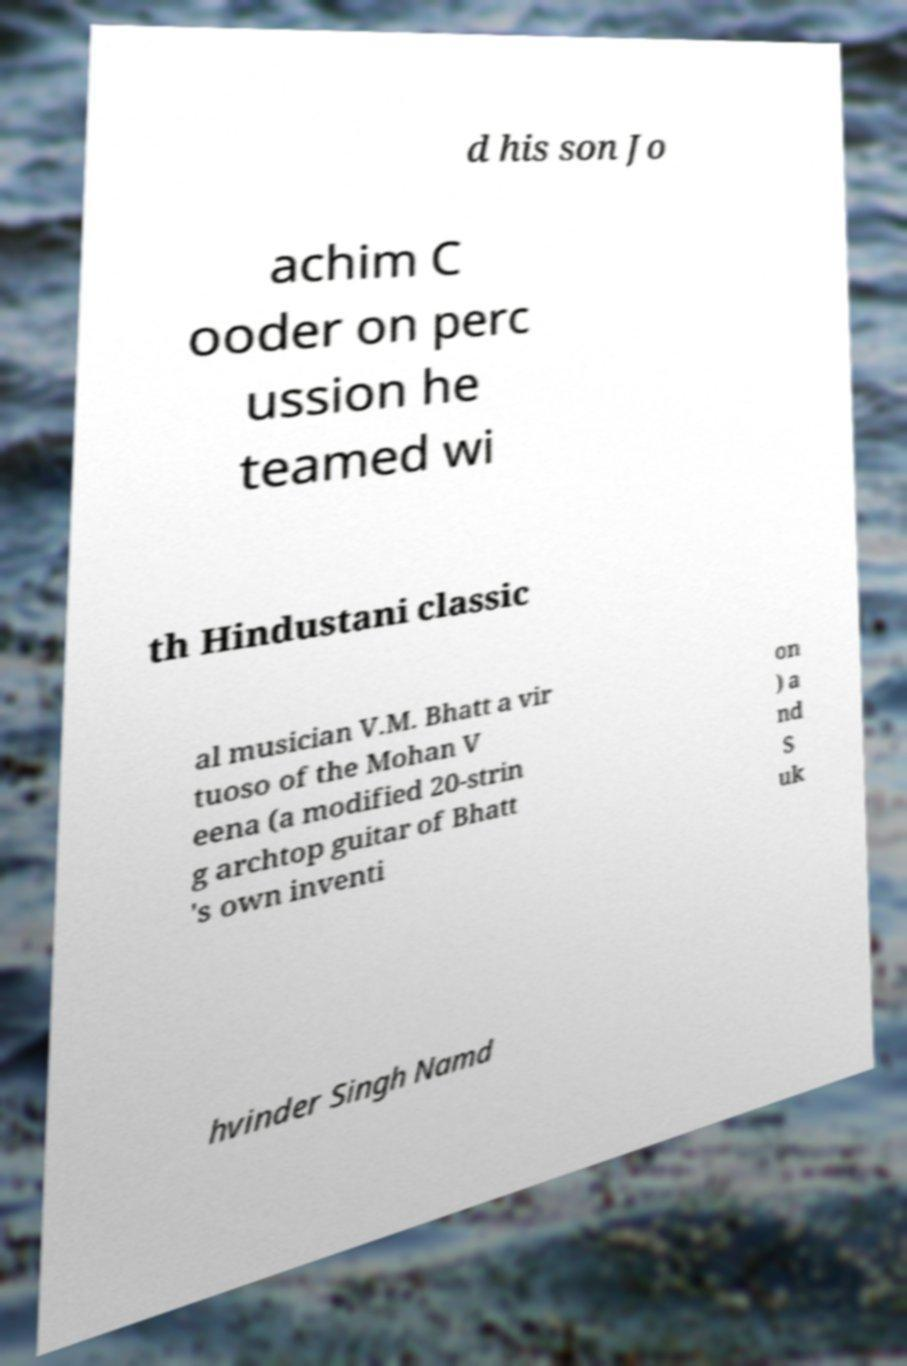Please read and relay the text visible in this image. What does it say? d his son Jo achim C ooder on perc ussion he teamed wi th Hindustani classic al musician V.M. Bhatt a vir tuoso of the Mohan V eena (a modified 20-strin g archtop guitar of Bhatt 's own inventi on ) a nd S uk hvinder Singh Namd 